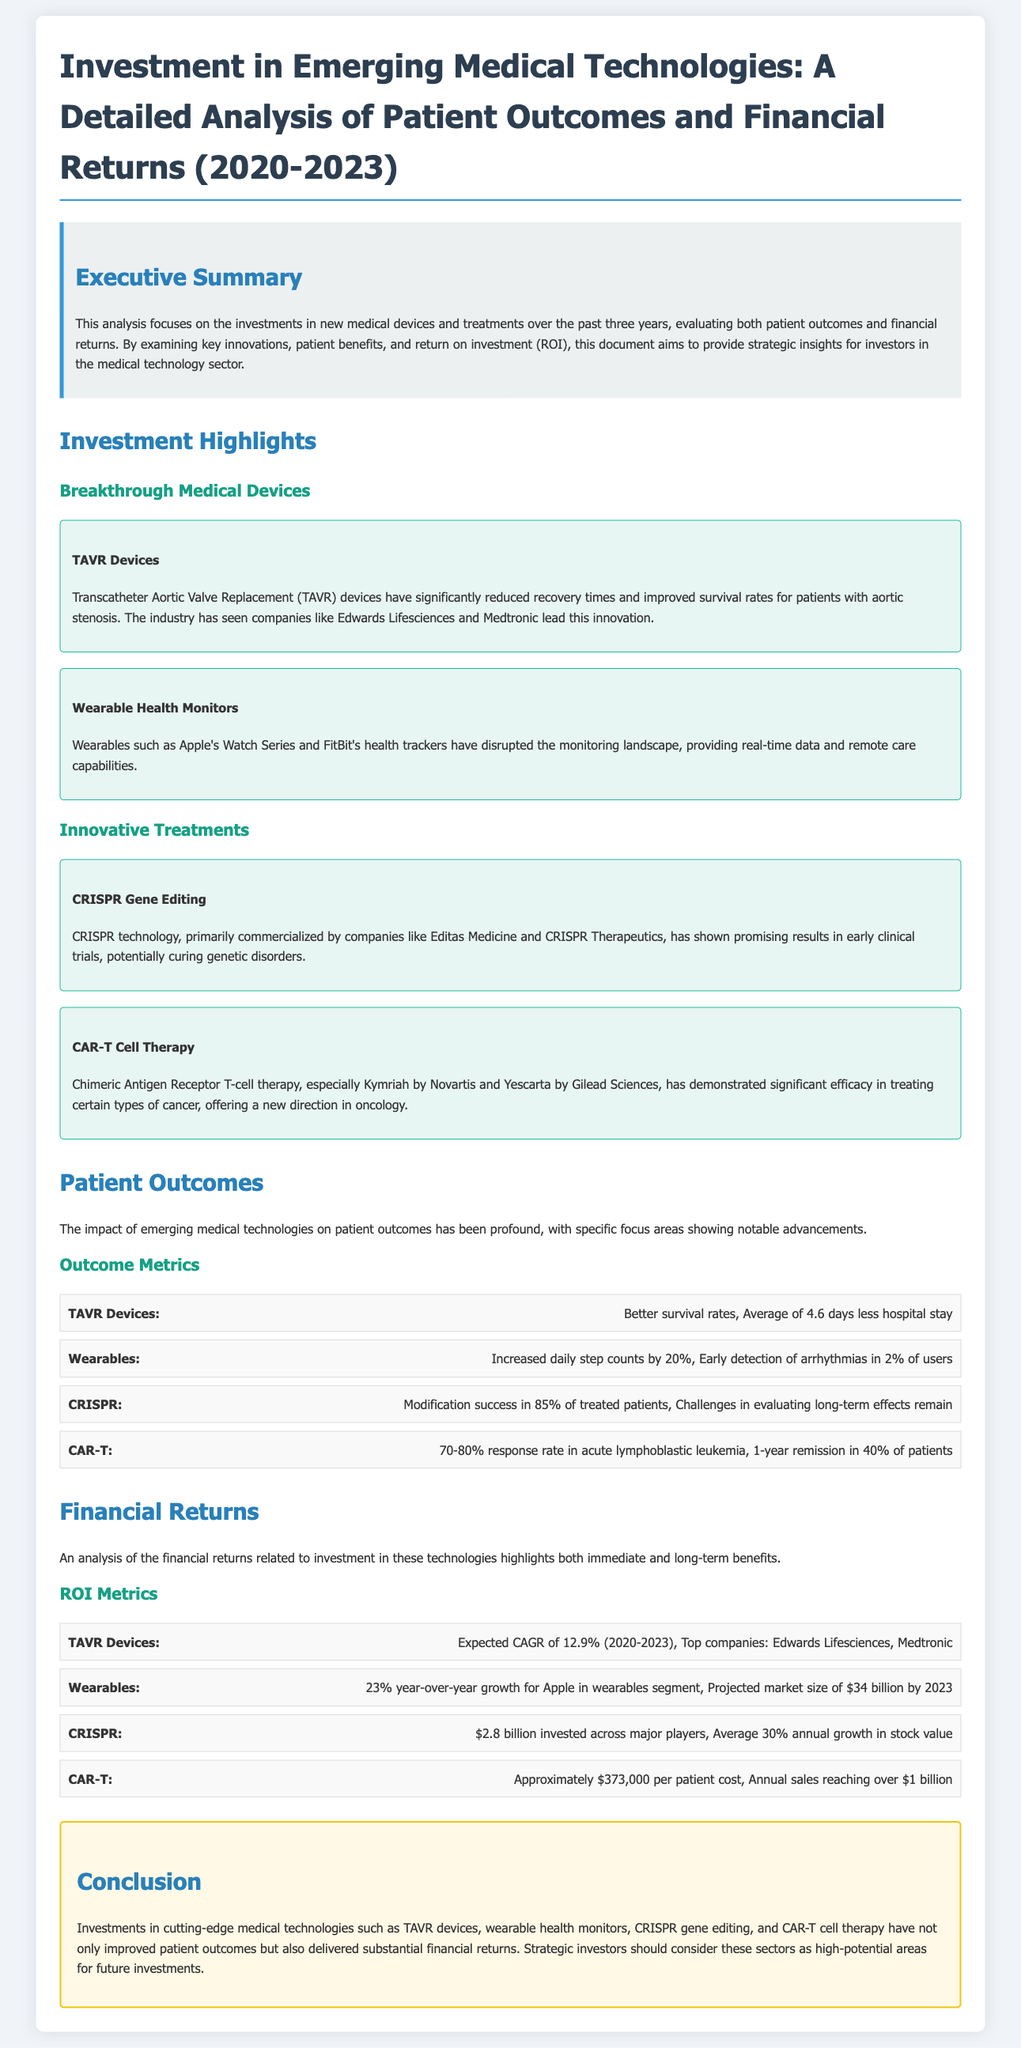What are TAVR Devices? TAVR Devices are Transcatheter Aortic Valve Replacement devices that improve survival rates for patients with aortic stenosis.
Answer: Transcatheter Aortic Valve Replacement devices What is the average reduction in hospital stay for TAVR patients? The document states that TAVR devices have led to an average of 4.6 days less hospital stay for patients.
Answer: 4.6 days What is the projected market size for wearables by 2023? According to the document, the projected market size for wearables is $34 billion by 2023.
Answer: $34 billion What is the expected CAGR for TAVR devices from 2020-2023? The expected compound annual growth rate (CAGR) for TAVR devices during this period is mentioned as 12.9%.
Answer: 12.9% What is the response rate for CAR-T therapy in acute lymphoblastic leukemia? The document indicates a response rate of 70-80% for CAR-T therapy in acute lymphoblastic leukemia.
Answer: 70-80% How much was invested across major players in CRISPR technology? The analysis mentions a total investment of $2.8 billion across major players in CRISPR.
Answer: $2.8 billion What is the estimated annual sales for CAR-T therapies? The document states that annual sales for CAR-T therapies are reaching over $1 billion.
Answer: Over $1 billion What are the top companies associated with TAVR devices? The key companies leading the market in TAVR devices include Edwards Lifesciences and Medtronic.
Answer: Edwards Lifesciences, Medtronic What is the benefit of wearable health monitors mentioned in the document? Wearable health monitors have increased daily step counts by 20% and can detect arrhythmias early in 2% of users.
Answer: Increased daily step counts by 20% and early detection of arrhythmias 